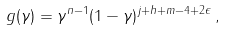<formula> <loc_0><loc_0><loc_500><loc_500>g ( \gamma ) = \gamma ^ { n - 1 } ( 1 - \gamma ) ^ { j + h + m - 4 + 2 \epsilon } \, ,</formula> 